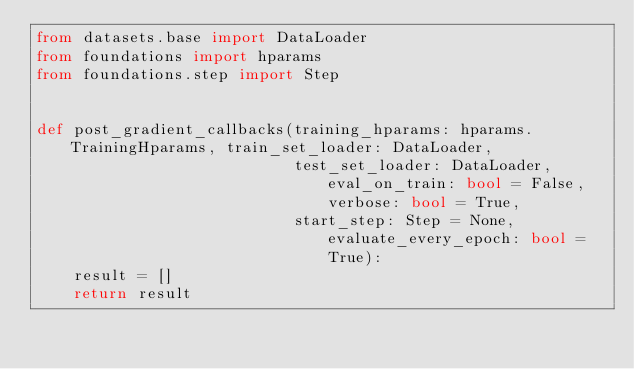Convert code to text. <code><loc_0><loc_0><loc_500><loc_500><_Python_>from datasets.base import DataLoader
from foundations import hparams
from foundations.step import Step


def post_gradient_callbacks(training_hparams: hparams.TrainingHparams, train_set_loader: DataLoader,
                            test_set_loader: DataLoader, eval_on_train: bool = False, verbose: bool = True,
                            start_step: Step = None, evaluate_every_epoch: bool = True):
    result = []
    return result
</code> 